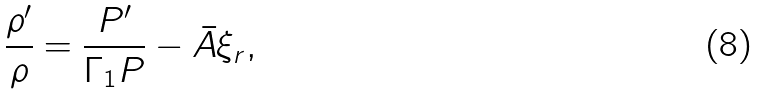Convert formula to latex. <formula><loc_0><loc_0><loc_500><loc_500>\frac { \rho ^ { \prime } } { \rho } = \frac { P ^ { \prime } } { \Gamma _ { 1 } P } - { \bar { A } } \xi _ { r } ,</formula> 